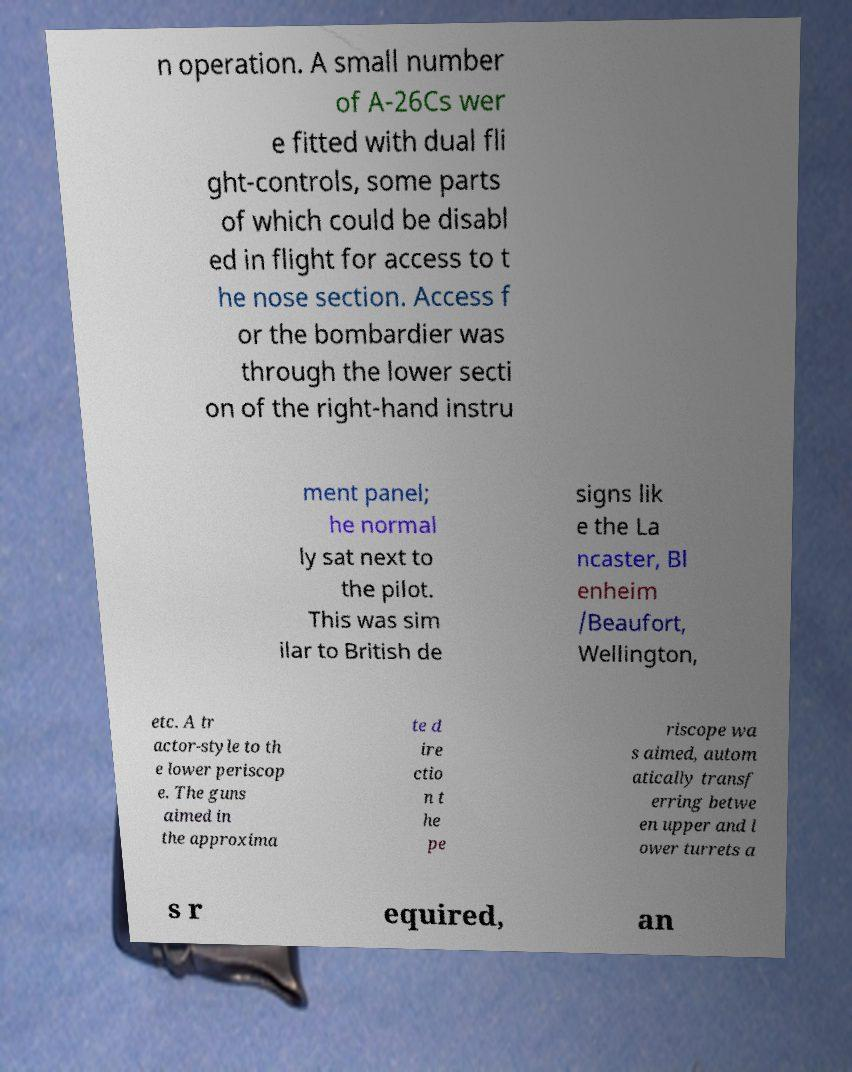Could you extract and type out the text from this image? n operation. A small number of A-26Cs wer e fitted with dual fli ght-controls, some parts of which could be disabl ed in flight for access to t he nose section. Access f or the bombardier was through the lower secti on of the right-hand instru ment panel; he normal ly sat next to the pilot. This was sim ilar to British de signs lik e the La ncaster, Bl enheim /Beaufort, Wellington, etc. A tr actor-style to th e lower periscop e. The guns aimed in the approxima te d ire ctio n t he pe riscope wa s aimed, autom atically transf erring betwe en upper and l ower turrets a s r equired, an 